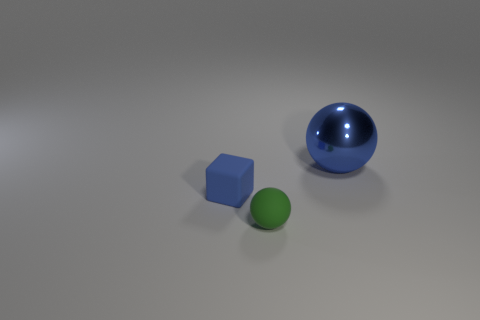Is there any other thing that is the same shape as the large blue metallic thing?
Make the answer very short. Yes. What color is the other object that is the same shape as the blue metal object?
Keep it short and to the point. Green. There is a small block that is the same material as the small ball; what color is it?
Keep it short and to the point. Blue. Are there an equal number of metallic objects on the right side of the large shiny ball and big metal objects?
Your answer should be compact. No. There is a blue object behind the blue rubber object; is it the same size as the green matte ball?
Your response must be concise. No. What is the color of the object that is the same size as the rubber block?
Your response must be concise. Green. There is a object that is behind the blue thing in front of the big shiny thing; is there a blue metallic object right of it?
Offer a very short reply. No. What is the material of the ball that is in front of the large blue object?
Ensure brevity in your answer.  Rubber. There is a tiny green rubber object; does it have the same shape as the thing that is on the right side of the matte sphere?
Provide a short and direct response. Yes. Is the number of green matte spheres behind the large object the same as the number of blue objects in front of the tiny green rubber thing?
Keep it short and to the point. Yes. 